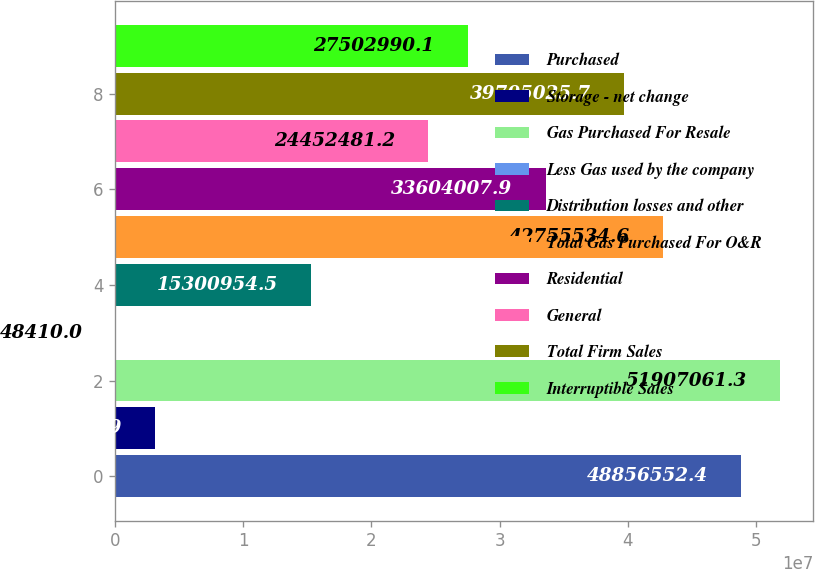<chart> <loc_0><loc_0><loc_500><loc_500><bar_chart><fcel>Purchased<fcel>Storage - net change<fcel>Gas Purchased For Resale<fcel>Less Gas used by the company<fcel>Distribution losses and other<fcel>Total Gas Purchased For O&R<fcel>Residential<fcel>General<fcel>Total Firm Sales<fcel>Interruptible Sales<nl><fcel>4.88566e+07<fcel>3.09892e+06<fcel>5.19071e+07<fcel>48410<fcel>1.5301e+07<fcel>4.27555e+07<fcel>3.3604e+07<fcel>2.44525e+07<fcel>3.9705e+07<fcel>2.7503e+07<nl></chart> 